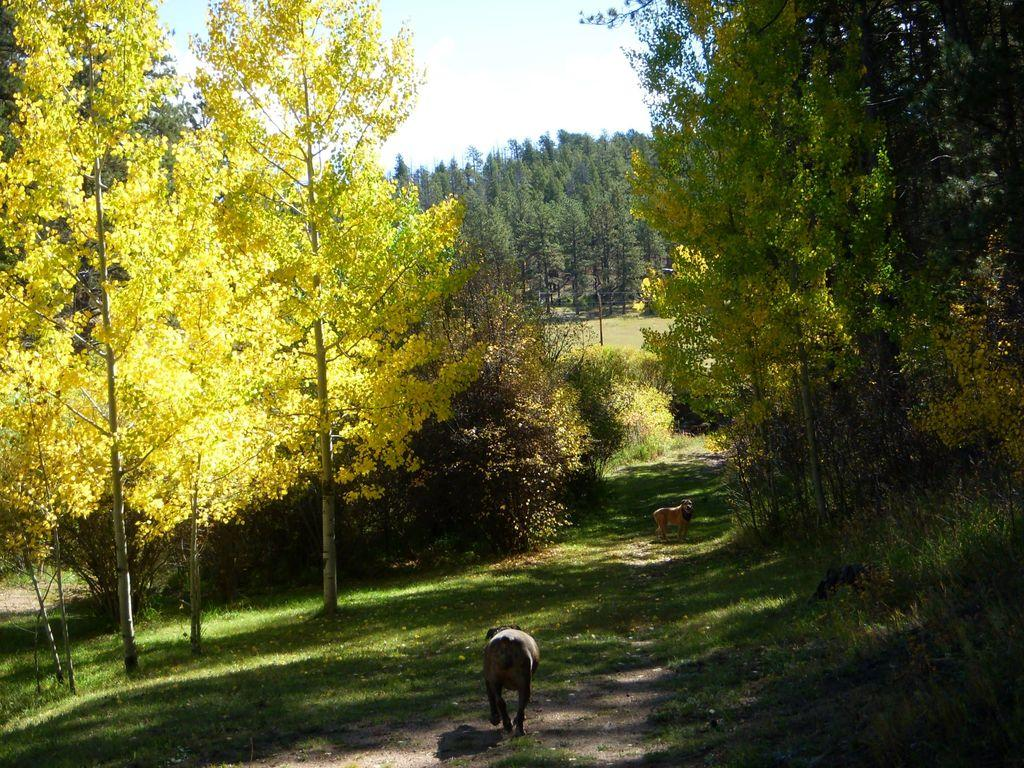What type of animals can be seen in the image? There are animals on the ground in the image. What can be seen in the background of the image? There is grass, trees, and the sky visible in the background of the image. What type of fruit is being turned into a rule in the image? There is no fruit or rule present in the image; it features animals on the ground with grass, trees, and the sky in the background. 